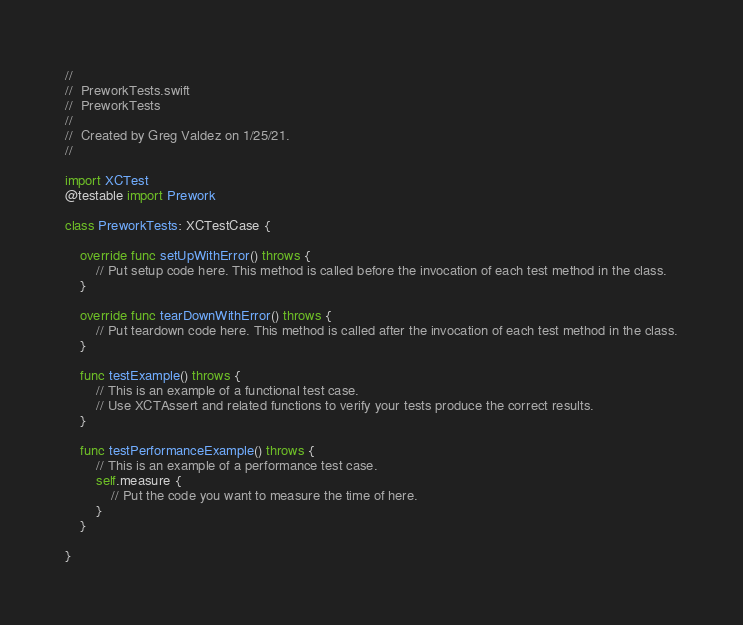<code> <loc_0><loc_0><loc_500><loc_500><_Swift_>//
//  PreworkTests.swift
//  PreworkTests
//
//  Created by Greg Valdez on 1/25/21.
//

import XCTest
@testable import Prework

class PreworkTests: XCTestCase {

    override func setUpWithError() throws {
        // Put setup code here. This method is called before the invocation of each test method in the class.
    }

    override func tearDownWithError() throws {
        // Put teardown code here. This method is called after the invocation of each test method in the class.
    }

    func testExample() throws {
        // This is an example of a functional test case.
        // Use XCTAssert and related functions to verify your tests produce the correct results.
    }

    func testPerformanceExample() throws {
        // This is an example of a performance test case.
        self.measure {
            // Put the code you want to measure the time of here.
        }
    }

}
</code> 